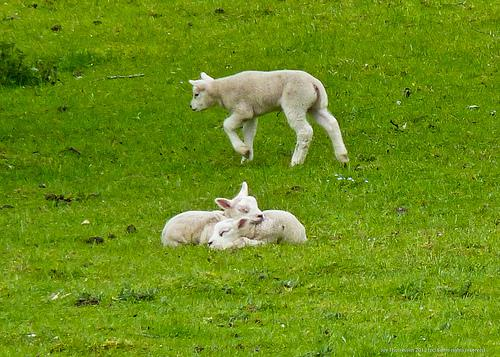Question: why is the photo empty?
Choices:
A. The lens was covered.
B. There is noone.
C. It was too dark.
D. Too much light.
Answer with the letter. Answer: B Question: how is the photo?
Choices:
A. Foggy.
B. Clear.
C. Pixelated.
D. Dark.
Answer with the letter. Answer: B Question: where was this photo taken?
Choices:
A. In the grass.
B. On a hill.
C. In a park.
D. Theme park.
Answer with the letter. Answer: A 